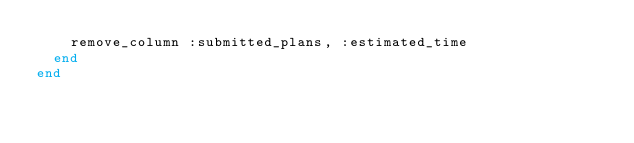<code> <loc_0><loc_0><loc_500><loc_500><_Ruby_>    remove_column :submitted_plans, :estimated_time
  end
end
</code> 